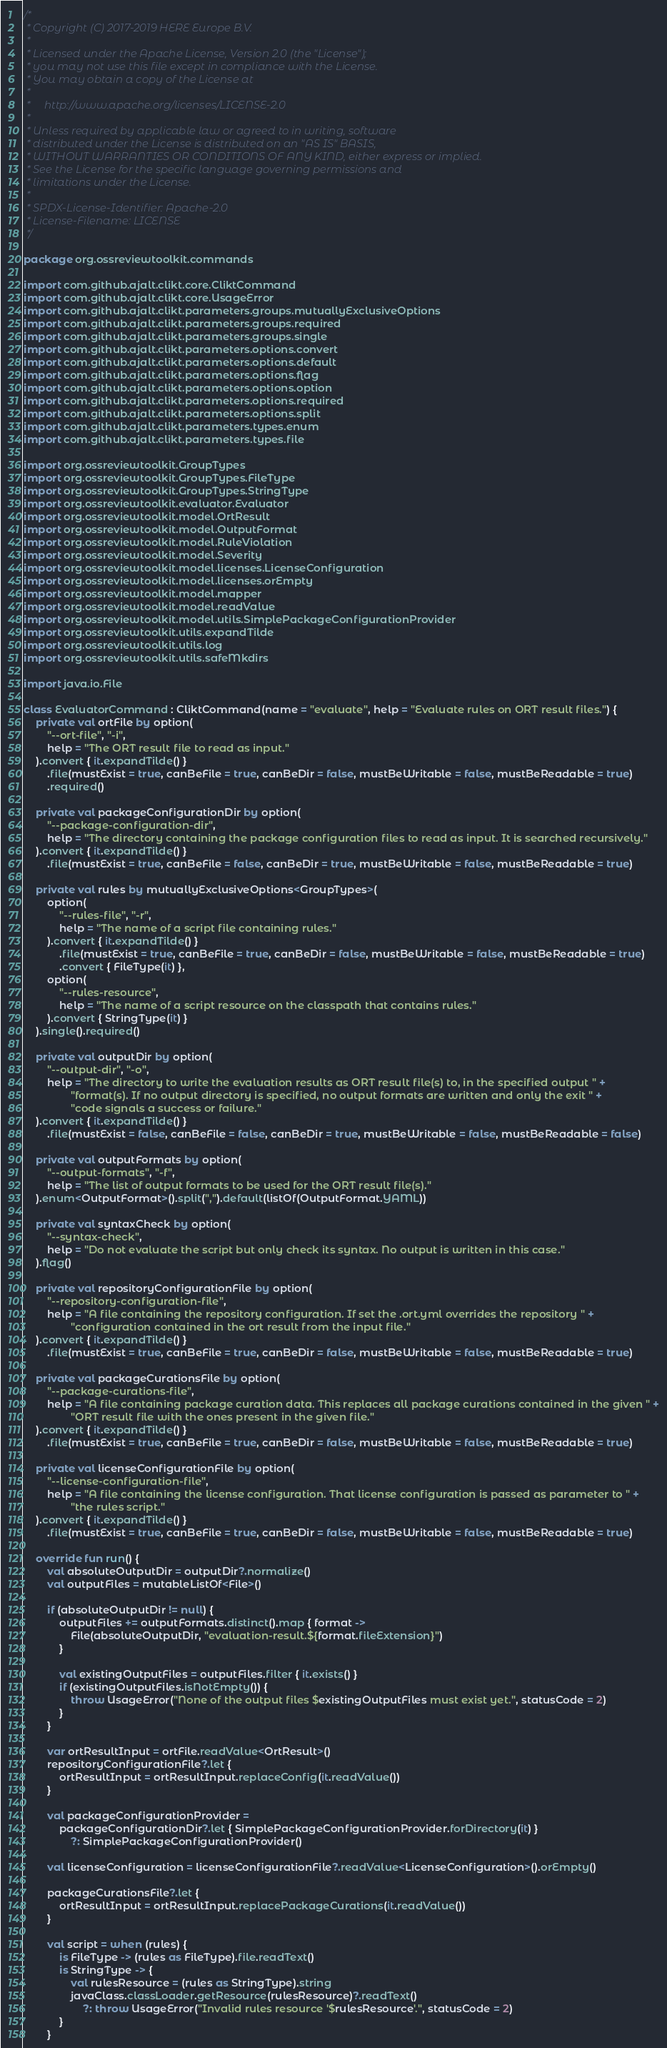Convert code to text. <code><loc_0><loc_0><loc_500><loc_500><_Kotlin_>/*
 * Copyright (C) 2017-2019 HERE Europe B.V.
 *
 * Licensed under the Apache License, Version 2.0 (the "License");
 * you may not use this file except in compliance with the License.
 * You may obtain a copy of the License at
 *
 *     http://www.apache.org/licenses/LICENSE-2.0
 *
 * Unless required by applicable law or agreed to in writing, software
 * distributed under the License is distributed on an "AS IS" BASIS,
 * WITHOUT WARRANTIES OR CONDITIONS OF ANY KIND, either express or implied.
 * See the License for the specific language governing permissions and
 * limitations under the License.
 *
 * SPDX-License-Identifier: Apache-2.0
 * License-Filename: LICENSE
 */

package org.ossreviewtoolkit.commands

import com.github.ajalt.clikt.core.CliktCommand
import com.github.ajalt.clikt.core.UsageError
import com.github.ajalt.clikt.parameters.groups.mutuallyExclusiveOptions
import com.github.ajalt.clikt.parameters.groups.required
import com.github.ajalt.clikt.parameters.groups.single
import com.github.ajalt.clikt.parameters.options.convert
import com.github.ajalt.clikt.parameters.options.default
import com.github.ajalt.clikt.parameters.options.flag
import com.github.ajalt.clikt.parameters.options.option
import com.github.ajalt.clikt.parameters.options.required
import com.github.ajalt.clikt.parameters.options.split
import com.github.ajalt.clikt.parameters.types.enum
import com.github.ajalt.clikt.parameters.types.file

import org.ossreviewtoolkit.GroupTypes
import org.ossreviewtoolkit.GroupTypes.FileType
import org.ossreviewtoolkit.GroupTypes.StringType
import org.ossreviewtoolkit.evaluator.Evaluator
import org.ossreviewtoolkit.model.OrtResult
import org.ossreviewtoolkit.model.OutputFormat
import org.ossreviewtoolkit.model.RuleViolation
import org.ossreviewtoolkit.model.Severity
import org.ossreviewtoolkit.model.licenses.LicenseConfiguration
import org.ossreviewtoolkit.model.licenses.orEmpty
import org.ossreviewtoolkit.model.mapper
import org.ossreviewtoolkit.model.readValue
import org.ossreviewtoolkit.model.utils.SimplePackageConfigurationProvider
import org.ossreviewtoolkit.utils.expandTilde
import org.ossreviewtoolkit.utils.log
import org.ossreviewtoolkit.utils.safeMkdirs

import java.io.File

class EvaluatorCommand : CliktCommand(name = "evaluate", help = "Evaluate rules on ORT result files.") {
    private val ortFile by option(
        "--ort-file", "-i",
        help = "The ORT result file to read as input."
    ).convert { it.expandTilde() }
        .file(mustExist = true, canBeFile = true, canBeDir = false, mustBeWritable = false, mustBeReadable = true)
        .required()

    private val packageConfigurationDir by option(
        "--package-configuration-dir",
        help = "The directory containing the package configuration files to read as input. It is searched recursively."
    ).convert { it.expandTilde() }
        .file(mustExist = true, canBeFile = false, canBeDir = true, mustBeWritable = false, mustBeReadable = true)

    private val rules by mutuallyExclusiveOptions<GroupTypes>(
        option(
            "--rules-file", "-r",
            help = "The name of a script file containing rules."
        ).convert { it.expandTilde() }
            .file(mustExist = true, canBeFile = true, canBeDir = false, mustBeWritable = false, mustBeReadable = true)
            .convert { FileType(it) },
        option(
            "--rules-resource",
            help = "The name of a script resource on the classpath that contains rules."
        ).convert { StringType(it) }
    ).single().required()

    private val outputDir by option(
        "--output-dir", "-o",
        help = "The directory to write the evaluation results as ORT result file(s) to, in the specified output " +
                "format(s). If no output directory is specified, no output formats are written and only the exit " +
                "code signals a success or failure."
    ).convert { it.expandTilde() }
        .file(mustExist = false, canBeFile = false, canBeDir = true, mustBeWritable = false, mustBeReadable = false)

    private val outputFormats by option(
        "--output-formats", "-f",
        help = "The list of output formats to be used for the ORT result file(s)."
    ).enum<OutputFormat>().split(",").default(listOf(OutputFormat.YAML))

    private val syntaxCheck by option(
        "--syntax-check",
        help = "Do not evaluate the script but only check its syntax. No output is written in this case."
    ).flag()

    private val repositoryConfigurationFile by option(
        "--repository-configuration-file",
        help = "A file containing the repository configuration. If set the .ort.yml overrides the repository " +
                "configuration contained in the ort result from the input file."
    ).convert { it.expandTilde() }
        .file(mustExist = true, canBeFile = true, canBeDir = false, mustBeWritable = false, mustBeReadable = true)

    private val packageCurationsFile by option(
        "--package-curations-file",
        help = "A file containing package curation data. This replaces all package curations contained in the given " +
                "ORT result file with the ones present in the given file."
    ).convert { it.expandTilde() }
        .file(mustExist = true, canBeFile = true, canBeDir = false, mustBeWritable = false, mustBeReadable = true)

    private val licenseConfigurationFile by option(
        "--license-configuration-file",
        help = "A file containing the license configuration. That license configuration is passed as parameter to " +
                "the rules script."
    ).convert { it.expandTilde() }
        .file(mustExist = true, canBeFile = true, canBeDir = false, mustBeWritable = false, mustBeReadable = true)

    override fun run() {
        val absoluteOutputDir = outputDir?.normalize()
        val outputFiles = mutableListOf<File>()

        if (absoluteOutputDir != null) {
            outputFiles += outputFormats.distinct().map { format ->
                File(absoluteOutputDir, "evaluation-result.${format.fileExtension}")
            }

            val existingOutputFiles = outputFiles.filter { it.exists() }
            if (existingOutputFiles.isNotEmpty()) {
                throw UsageError("None of the output files $existingOutputFiles must exist yet.", statusCode = 2)
            }
        }

        var ortResultInput = ortFile.readValue<OrtResult>()
        repositoryConfigurationFile?.let {
            ortResultInput = ortResultInput.replaceConfig(it.readValue())
        }

        val packageConfigurationProvider =
            packageConfigurationDir?.let { SimplePackageConfigurationProvider.forDirectory(it) }
                ?: SimplePackageConfigurationProvider()

        val licenseConfiguration = licenseConfigurationFile?.readValue<LicenseConfiguration>().orEmpty()

        packageCurationsFile?.let {
            ortResultInput = ortResultInput.replacePackageCurations(it.readValue())
        }

        val script = when (rules) {
            is FileType -> (rules as FileType).file.readText()
            is StringType -> {
                val rulesResource = (rules as StringType).string
                javaClass.classLoader.getResource(rulesResource)?.readText()
                    ?: throw UsageError("Invalid rules resource '$rulesResource'.", statusCode = 2)
            }
        }
</code> 